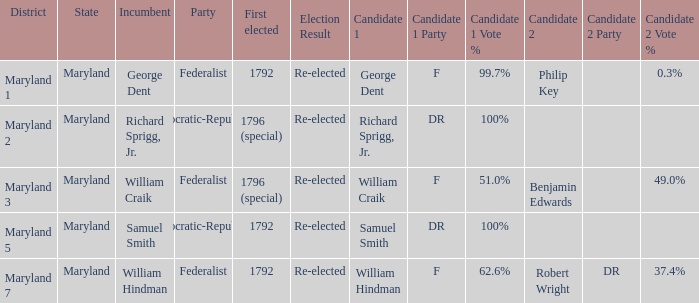Who are the aspirants for maryland's 1st district? George Dent (F) 99.7% Philip Key 0.3%. 